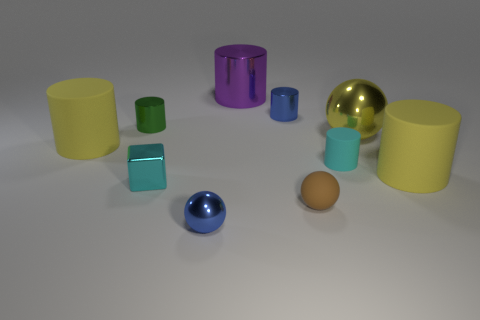What number of balls are brown objects or small metallic objects?
Make the answer very short. 2. How many shiny things are cylinders or large red things?
Offer a very short reply. 3. What is the size of the cyan thing that is the same shape as the green metal object?
Provide a short and direct response. Small. There is a rubber sphere; does it have the same size as the yellow matte thing that is on the right side of the yellow metal sphere?
Your answer should be compact. No. The yellow object left of the small blue cylinder has what shape?
Keep it short and to the point. Cylinder. The small metal cylinder that is on the right side of the shiny sphere left of the tiny brown ball is what color?
Ensure brevity in your answer.  Blue. There is a big shiny thing that is the same shape as the small cyan rubber object; what is its color?
Provide a short and direct response. Purple. How many rubber cylinders are the same color as the large metallic ball?
Offer a terse response. 2. There is a small rubber cylinder; does it have the same color as the tiny metallic block that is to the left of the brown matte sphere?
Ensure brevity in your answer.  Yes. What shape is the big object that is both in front of the big yellow metallic ball and on the left side of the brown rubber ball?
Ensure brevity in your answer.  Cylinder. 